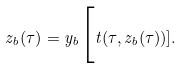Convert formula to latex. <formula><loc_0><loc_0><loc_500><loc_500>z _ { b } ( \tau ) = y _ { b } \Big [ t ( \tau , z _ { b } ( \tau ) ) ] .</formula> 